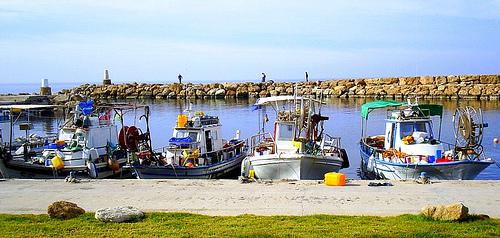Question: why are the boats here?
Choices:
A. To pick up passengers.
B. To take a break.
C. To eat.
D. To get fixed.
Answer with the letter. Answer: B Question: who was on the boats?
Choices:
A. Visitors.
B. Tourists.
C. People.
D. Couples.
Answer with the letter. Answer: C Question: what are the boats for?
Choices:
A. Recreation.
B. For transport.
C. Fishing.
D. Tourism.
Answer with the letter. Answer: B Question: where are they currently?
Choices:
A. At bay.
B. In the water.
C. On the ocean.
D. At sea.
Answer with the letter. Answer: A 